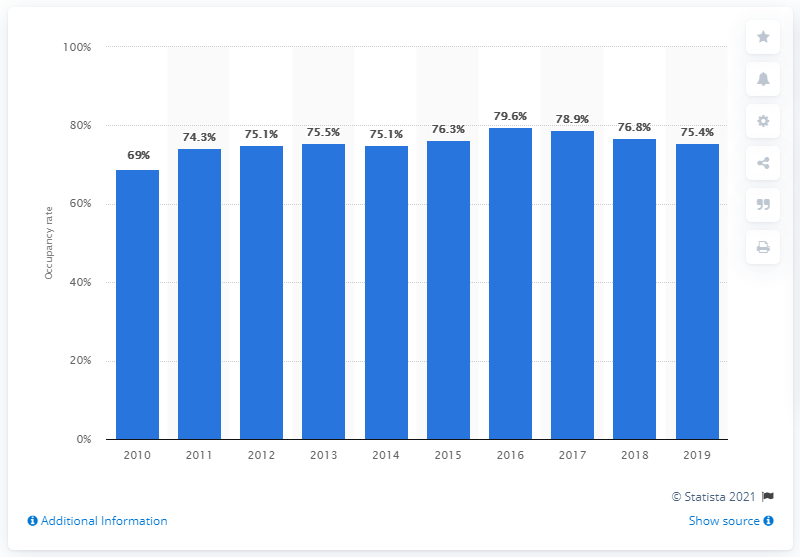Mention a couple of crucial points in this snapshot. The occupancy rate of hotels in Mallorca in 2017 was 79.6%. In 2016, the annual occupancy rate of hotel beds was 79.6%. 